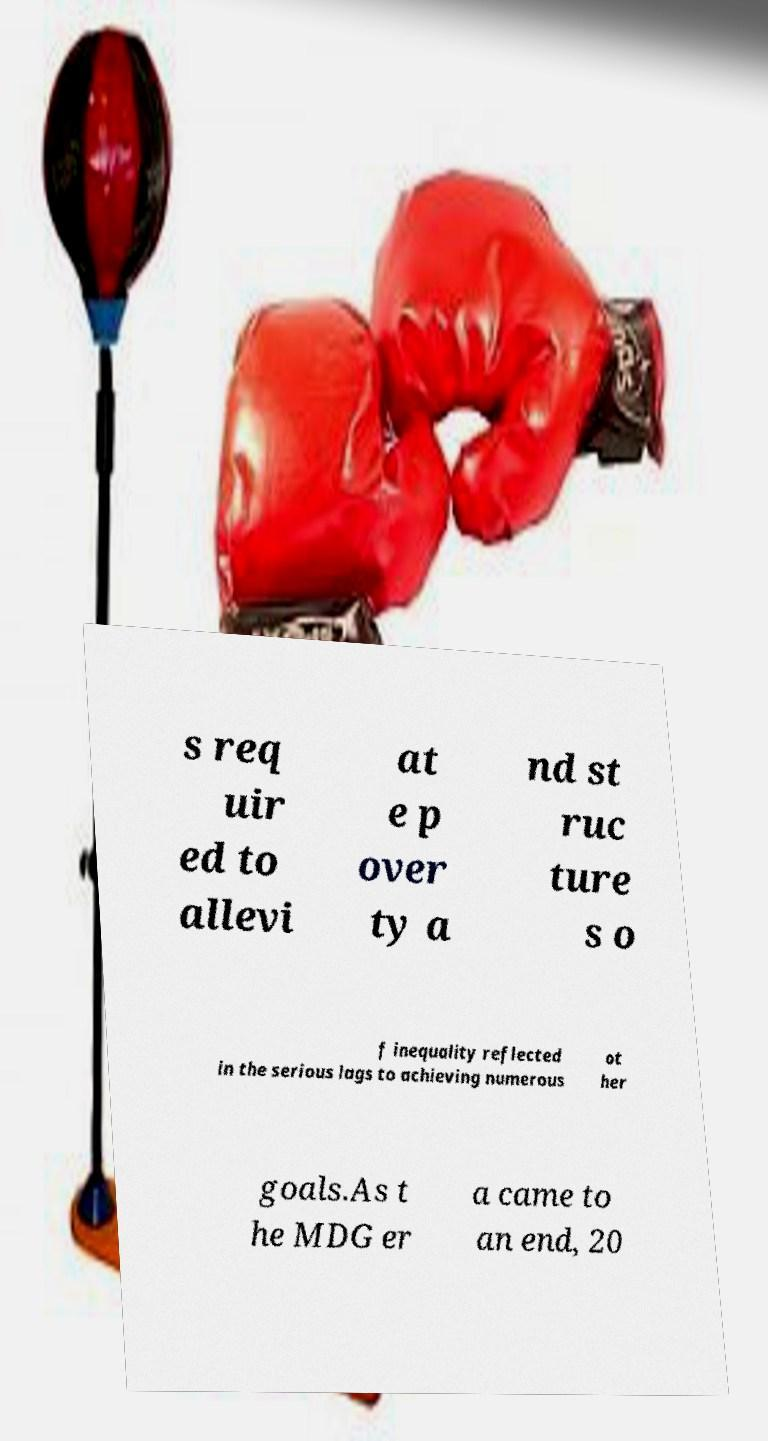I need the written content from this picture converted into text. Can you do that? s req uir ed to allevi at e p over ty a nd st ruc ture s o f inequality reflected in the serious lags to achieving numerous ot her goals.As t he MDG er a came to an end, 20 